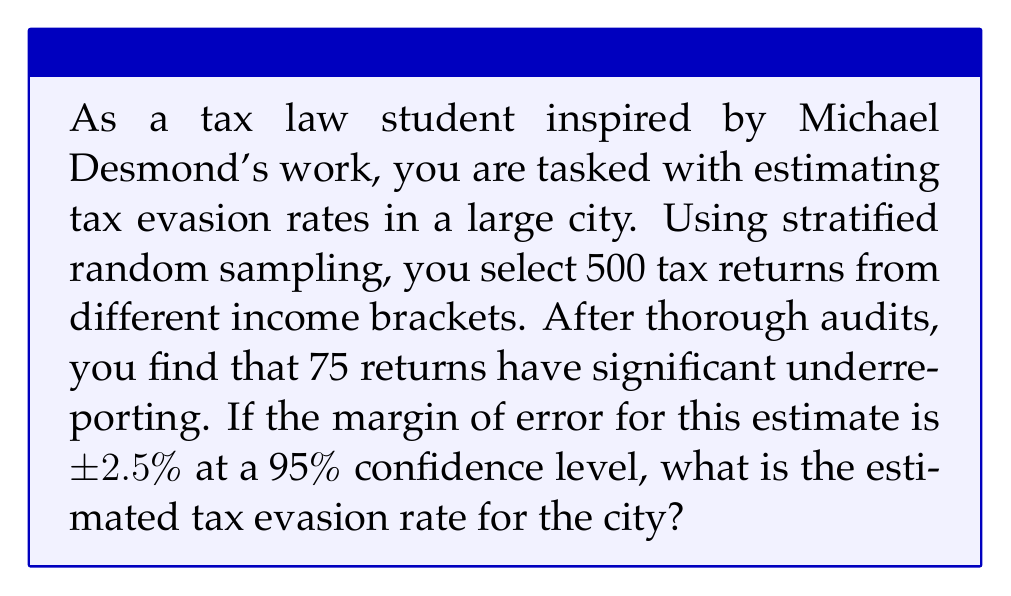Could you help me with this problem? To solve this problem, we'll follow these steps:

1. Calculate the sample proportion of tax evaders:
   $$p = \frac{\text{Number of tax evaders}}{\text{Total sample size}} = \frac{75}{500} = 0.15$$

2. The margin of error (ME) is given as ±2.5% or 0.025. For a 95% confidence level, we can use the formula:
   $$ME = z_{\frac{\alpha}{2}} \sqrt{\frac{p(1-p)}{n}}$$
   where $z_{\frac{\alpha}{2}}$ is the z-score for a 95% confidence level (1.96).

3. We don't need to calculate the margin of error since it's given. The estimated tax evasion rate is the sample proportion ± the margin of error:
   $$\text{Estimated rate} = p \pm ME = 0.15 \pm 0.025$$

4. Therefore, the estimated tax evasion rate for the city is between 12.5% and 17.5%.

5. To express this as a single value with the margin of error, we can write:
   $$\text{Estimated tax evasion rate} = 15\% \pm 2.5\%$$
Answer: 15% ± 2.5% 